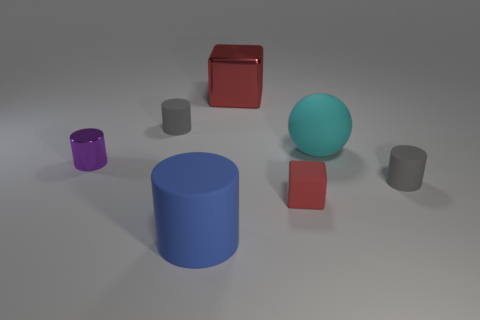How many objects are smaller than the turquoise sphere? Judging by the image, there are five objects that appear to be smaller than the turquoise sphere. These include three cubes and two objects that resemble small cylinders or cups.  Could you tell me about the lighting in the scene? The lighting in the scene is subdued and diffused, suggesting an indoor environment with soft light sources. The shadows cast by the objects are soft-edged and fall to the right of the objects, indicating the light source is coming from the upper left side of the frame. 